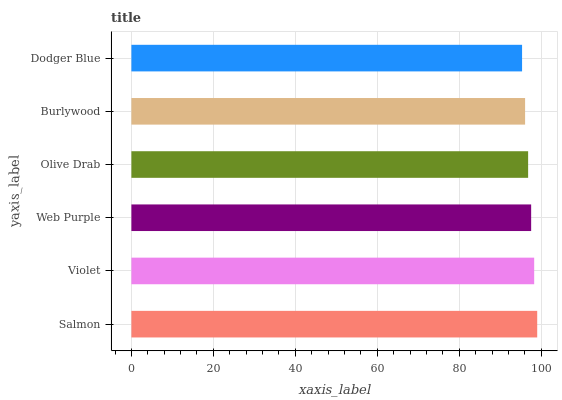Is Dodger Blue the minimum?
Answer yes or no. Yes. Is Salmon the maximum?
Answer yes or no. Yes. Is Violet the minimum?
Answer yes or no. No. Is Violet the maximum?
Answer yes or no. No. Is Salmon greater than Violet?
Answer yes or no. Yes. Is Violet less than Salmon?
Answer yes or no. Yes. Is Violet greater than Salmon?
Answer yes or no. No. Is Salmon less than Violet?
Answer yes or no. No. Is Web Purple the high median?
Answer yes or no. Yes. Is Olive Drab the low median?
Answer yes or no. Yes. Is Burlywood the high median?
Answer yes or no. No. Is Dodger Blue the low median?
Answer yes or no. No. 